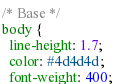<code> <loc_0><loc_0><loc_500><loc_500><_CSS_>/* Base */
body {
  line-height: 1.7;
  color: #4d4d4d;
  font-weight: 400;</code> 